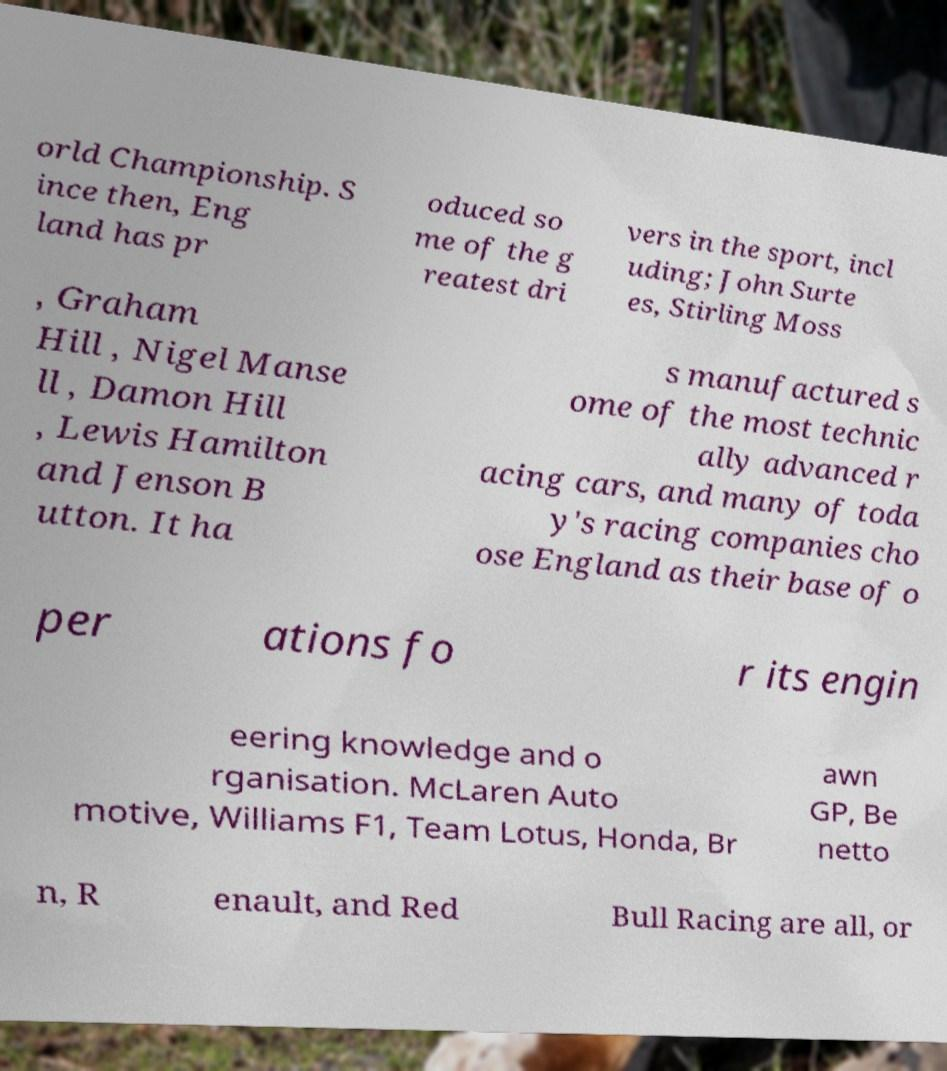There's text embedded in this image that I need extracted. Can you transcribe it verbatim? orld Championship. S ince then, Eng land has pr oduced so me of the g reatest dri vers in the sport, incl uding; John Surte es, Stirling Moss , Graham Hill , Nigel Manse ll , Damon Hill , Lewis Hamilton and Jenson B utton. It ha s manufactured s ome of the most technic ally advanced r acing cars, and many of toda y's racing companies cho ose England as their base of o per ations fo r its engin eering knowledge and o rganisation. McLaren Auto motive, Williams F1, Team Lotus, Honda, Br awn GP, Be netto n, R enault, and Red Bull Racing are all, or 